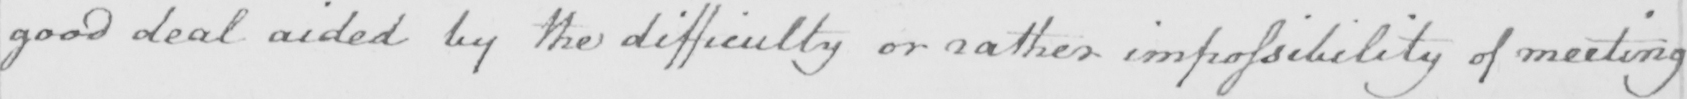Can you read and transcribe this handwriting? good deal aided by the difficulty or rather impossibility of meeting 